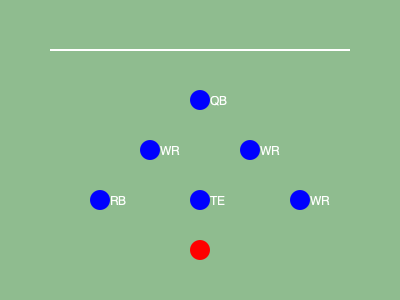Based on the offensive formation shown in the diagram, which type of formation is this, and what advantage does it provide to the offense? Let's analyze the formation step-by-step:

1. We can see 6 offensive players represented by blue circles.
2. The player at the top center is labeled "QB" (Quarterback), indicating the formation's starting point.
3. There are 3 players labeled "WR" (Wide Receiver) spread out in different positions.
4. One player is labeled "RB" (Running Back) in the backfield.
5. One player is labeled "TE" (Tight End) near the line of scrimmage.

This formation is known as the "Spread Formation." Here's why it's advantageous:

1. Spacing: The wide alignment of receivers stretches the defense horizontally, creating gaps in coverage.
2. Versatility: It allows for both passing and running plays, keeping the defense guessing.
3. Mismatches: Spreading receivers can force linebackers to cover faster players, creating favorable matchups.
4. Read options: The quarterback can quickly assess the defense and choose the best play option.
5. Simplified reads: With a clear view of the field, the quarterback can more easily identify defensive schemes.

This formation is particularly effective for teams with a mobile quarterback and skilled receivers, as it maximizes the field's width and creates multiple offensive options.
Answer: Spread Formation; creates spacing, versatility, and potential mismatches. 